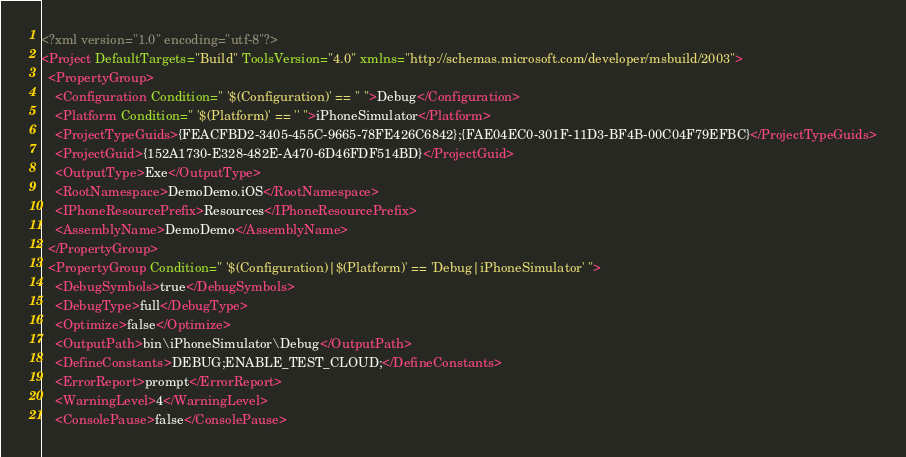Convert code to text. <code><loc_0><loc_0><loc_500><loc_500><_XML_><?xml version="1.0" encoding="utf-8"?>
<Project DefaultTargets="Build" ToolsVersion="4.0" xmlns="http://schemas.microsoft.com/developer/msbuild/2003">
  <PropertyGroup>
    <Configuration Condition=" '$(Configuration)' == '' ">Debug</Configuration>
    <Platform Condition=" '$(Platform)' == '' ">iPhoneSimulator</Platform>
    <ProjectTypeGuids>{FEACFBD2-3405-455C-9665-78FE426C6842};{FAE04EC0-301F-11D3-BF4B-00C04F79EFBC}</ProjectTypeGuids>
    <ProjectGuid>{152A1730-E328-482E-A470-6D46FDF514BD}</ProjectGuid>
    <OutputType>Exe</OutputType>
    <RootNamespace>DemoDemo.iOS</RootNamespace>
    <IPhoneResourcePrefix>Resources</IPhoneResourcePrefix>
    <AssemblyName>DemoDemo</AssemblyName>
  </PropertyGroup>
  <PropertyGroup Condition=" '$(Configuration)|$(Platform)' == 'Debug|iPhoneSimulator' ">
    <DebugSymbols>true</DebugSymbols>
    <DebugType>full</DebugType>
    <Optimize>false</Optimize>
    <OutputPath>bin\iPhoneSimulator\Debug</OutputPath>
    <DefineConstants>DEBUG;ENABLE_TEST_CLOUD;</DefineConstants>
    <ErrorReport>prompt</ErrorReport>
    <WarningLevel>4</WarningLevel>
    <ConsolePause>false</ConsolePause></code> 